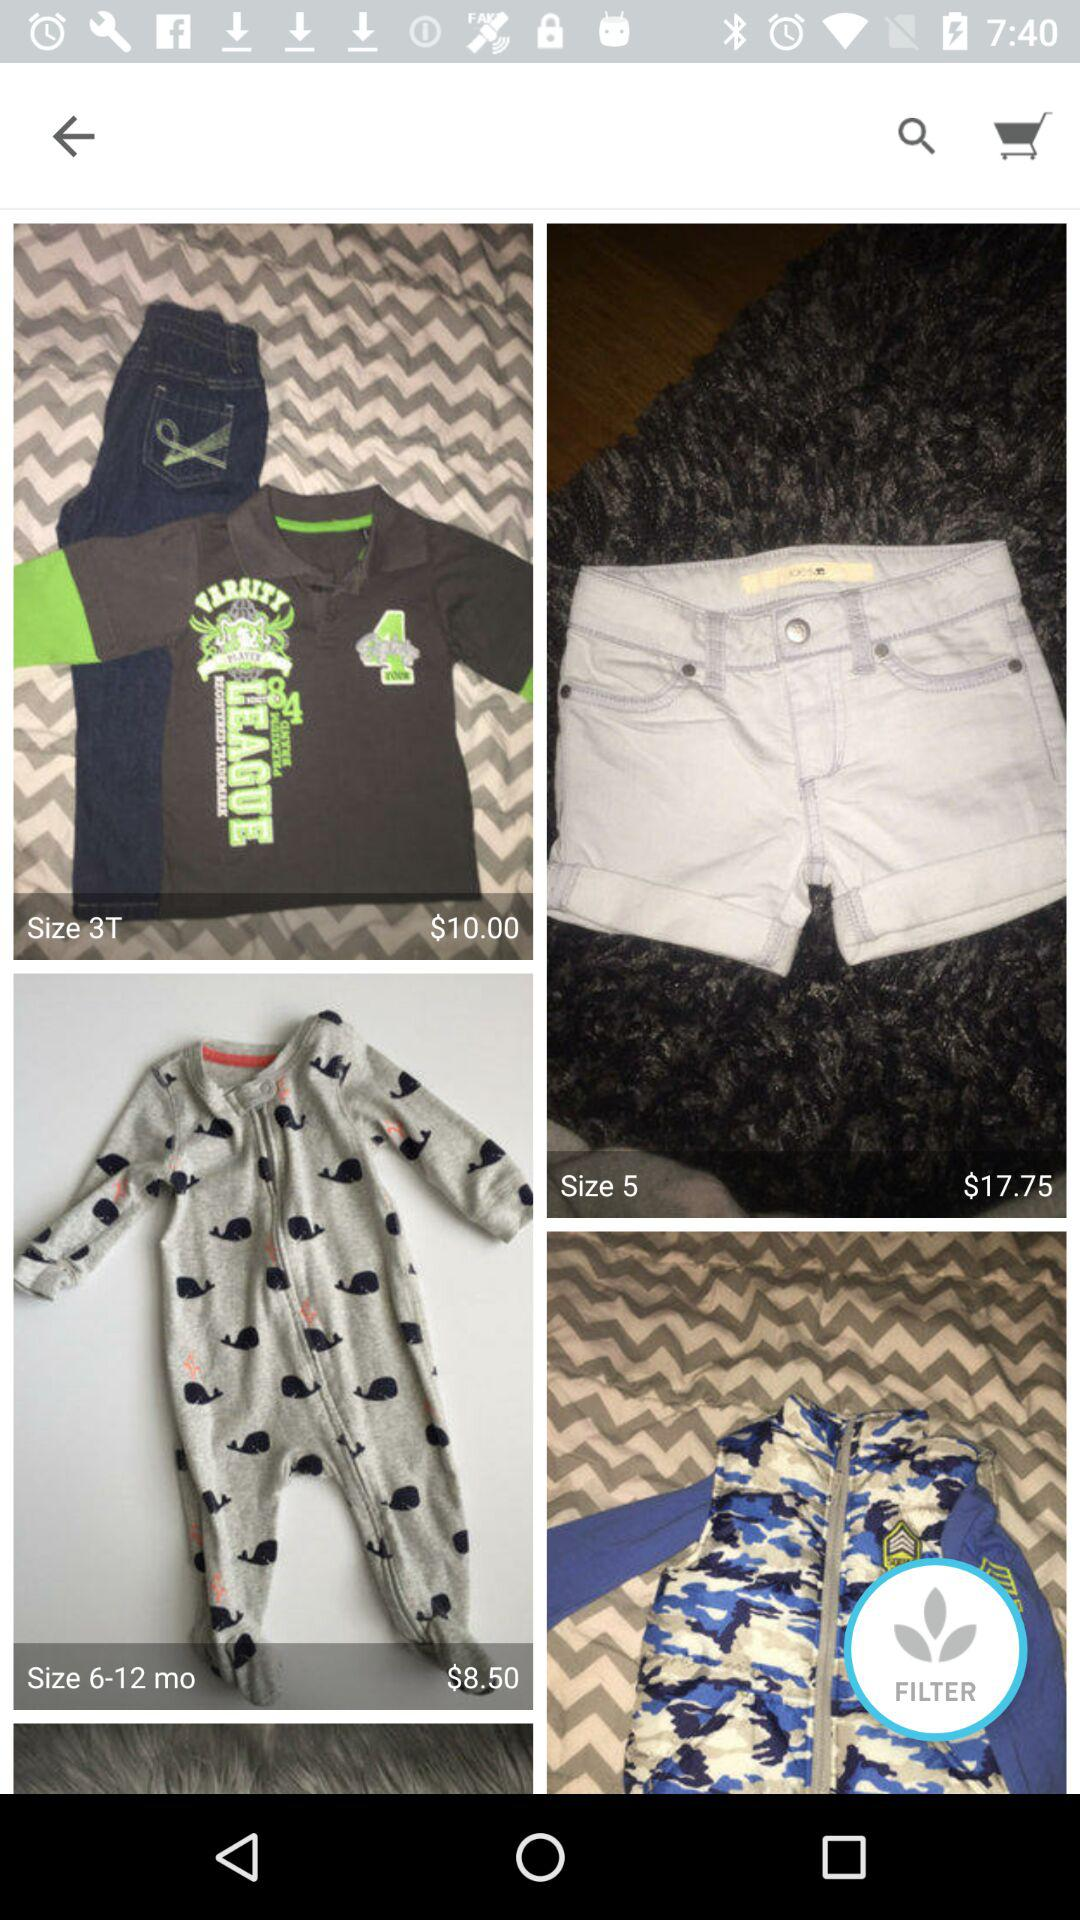What is the price of size 5 clothes? The price is $17.75. 